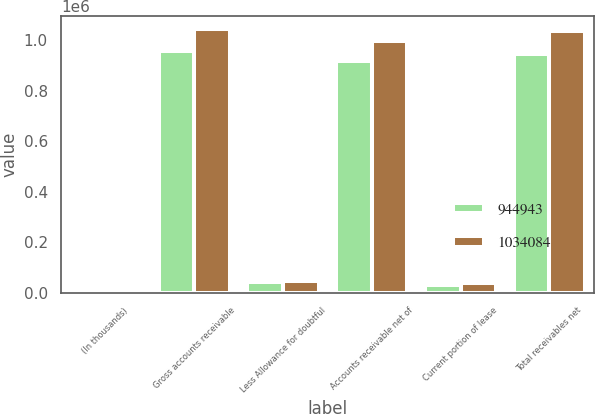Convert chart to OTSL. <chart><loc_0><loc_0><loc_500><loc_500><stacked_bar_chart><ecel><fcel>(In thousands)<fcel>Gross accounts receivable<fcel>Less Allowance for doubtful<fcel>Accounts receivable net of<fcel>Current portion of lease<fcel>Total receivables net<nl><fcel>944943<fcel>2016<fcel>958843<fcel>43028<fcel>915815<fcel>29128<fcel>944943<nl><fcel>1.03408e+06<fcel>2015<fcel>1.04307e+06<fcel>48119<fcel>994950<fcel>39134<fcel>1.03408e+06<nl></chart> 